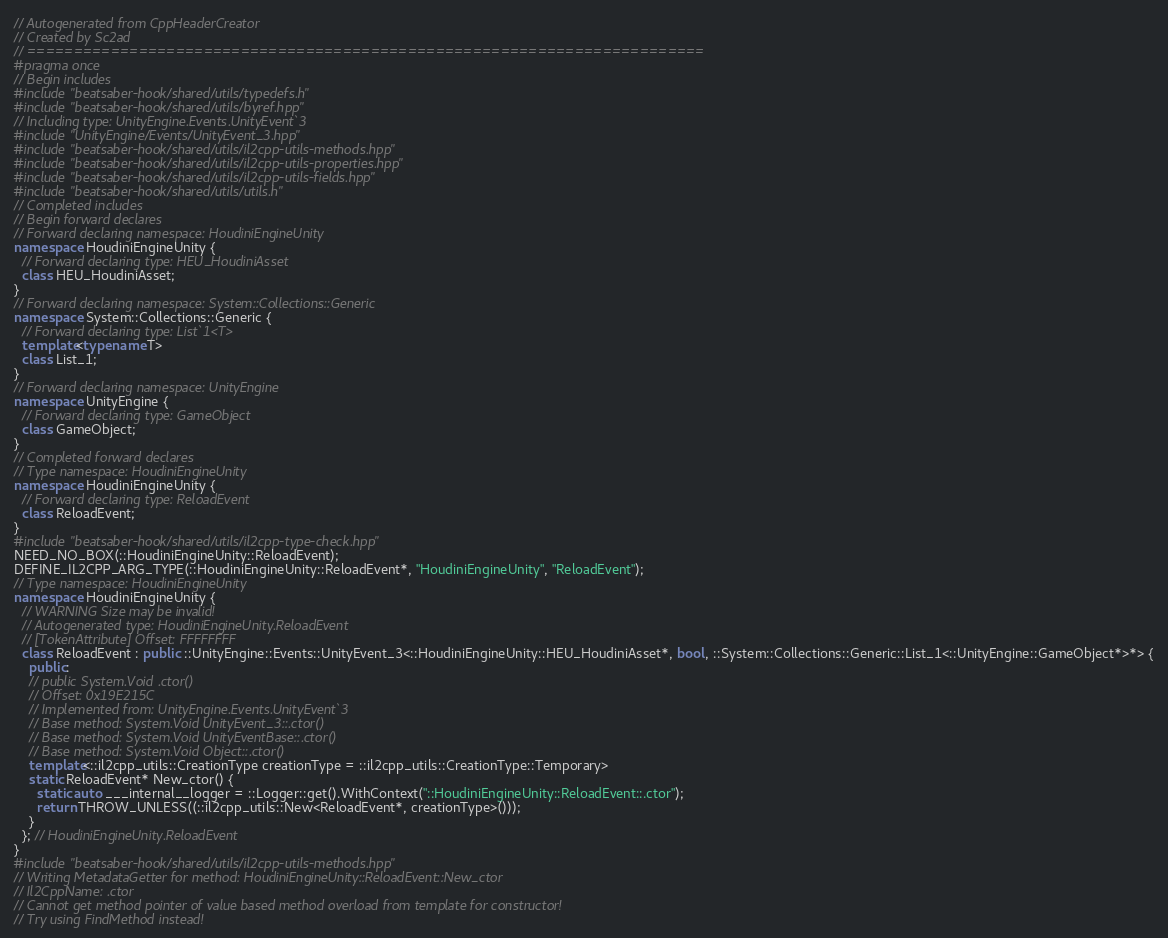Convert code to text. <code><loc_0><loc_0><loc_500><loc_500><_C++_>// Autogenerated from CppHeaderCreator
// Created by Sc2ad
// =========================================================================
#pragma once
// Begin includes
#include "beatsaber-hook/shared/utils/typedefs.h"
#include "beatsaber-hook/shared/utils/byref.hpp"
// Including type: UnityEngine.Events.UnityEvent`3
#include "UnityEngine/Events/UnityEvent_3.hpp"
#include "beatsaber-hook/shared/utils/il2cpp-utils-methods.hpp"
#include "beatsaber-hook/shared/utils/il2cpp-utils-properties.hpp"
#include "beatsaber-hook/shared/utils/il2cpp-utils-fields.hpp"
#include "beatsaber-hook/shared/utils/utils.h"
// Completed includes
// Begin forward declares
// Forward declaring namespace: HoudiniEngineUnity
namespace HoudiniEngineUnity {
  // Forward declaring type: HEU_HoudiniAsset
  class HEU_HoudiniAsset;
}
// Forward declaring namespace: System::Collections::Generic
namespace System::Collections::Generic {
  // Forward declaring type: List`1<T>
  template<typename T>
  class List_1;
}
// Forward declaring namespace: UnityEngine
namespace UnityEngine {
  // Forward declaring type: GameObject
  class GameObject;
}
// Completed forward declares
// Type namespace: HoudiniEngineUnity
namespace HoudiniEngineUnity {
  // Forward declaring type: ReloadEvent
  class ReloadEvent;
}
#include "beatsaber-hook/shared/utils/il2cpp-type-check.hpp"
NEED_NO_BOX(::HoudiniEngineUnity::ReloadEvent);
DEFINE_IL2CPP_ARG_TYPE(::HoudiniEngineUnity::ReloadEvent*, "HoudiniEngineUnity", "ReloadEvent");
// Type namespace: HoudiniEngineUnity
namespace HoudiniEngineUnity {
  // WARNING Size may be invalid!
  // Autogenerated type: HoudiniEngineUnity.ReloadEvent
  // [TokenAttribute] Offset: FFFFFFFF
  class ReloadEvent : public ::UnityEngine::Events::UnityEvent_3<::HoudiniEngineUnity::HEU_HoudiniAsset*, bool, ::System::Collections::Generic::List_1<::UnityEngine::GameObject*>*> {
    public:
    // public System.Void .ctor()
    // Offset: 0x19E215C
    // Implemented from: UnityEngine.Events.UnityEvent`3
    // Base method: System.Void UnityEvent_3::.ctor()
    // Base method: System.Void UnityEventBase::.ctor()
    // Base method: System.Void Object::.ctor()
    template<::il2cpp_utils::CreationType creationType = ::il2cpp_utils::CreationType::Temporary>
    static ReloadEvent* New_ctor() {
      static auto ___internal__logger = ::Logger::get().WithContext("::HoudiniEngineUnity::ReloadEvent::.ctor");
      return THROW_UNLESS((::il2cpp_utils::New<ReloadEvent*, creationType>()));
    }
  }; // HoudiniEngineUnity.ReloadEvent
}
#include "beatsaber-hook/shared/utils/il2cpp-utils-methods.hpp"
// Writing MetadataGetter for method: HoudiniEngineUnity::ReloadEvent::New_ctor
// Il2CppName: .ctor
// Cannot get method pointer of value based method overload from template for constructor!
// Try using FindMethod instead!
</code> 